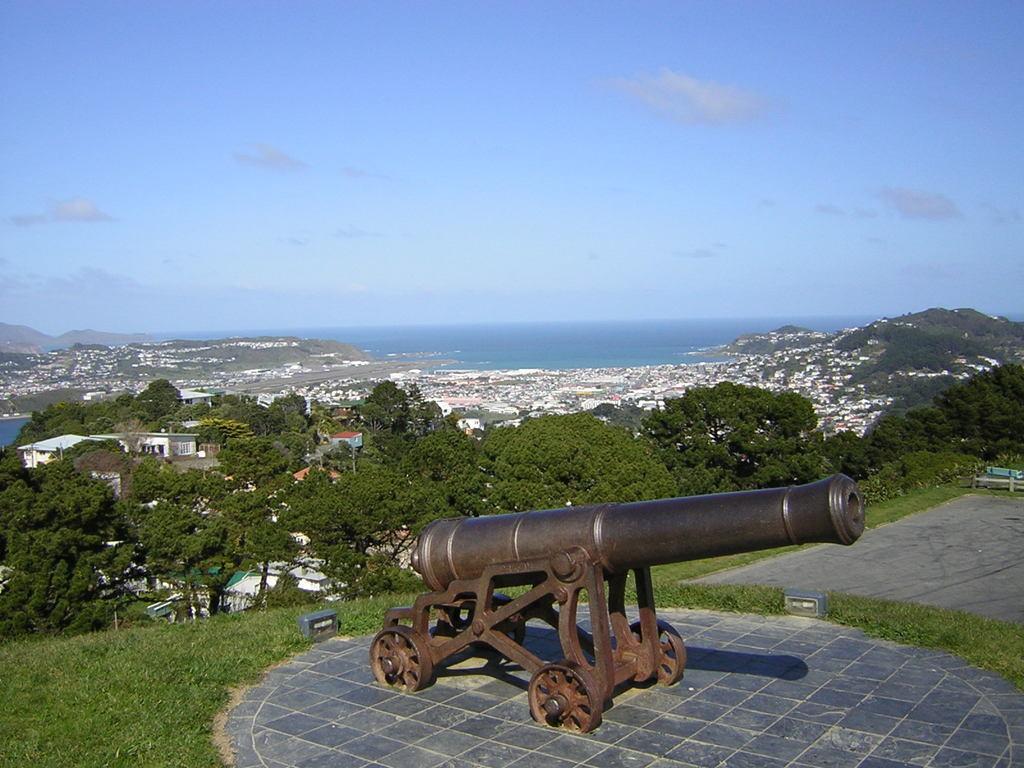Please provide a concise description of this image. In this image I see a cannon over here and I see the path and the green grass. In the background I see number of trees, buildings, water and the sky and I see a hill over here. 